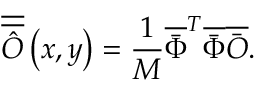<formula> <loc_0><loc_0><loc_500><loc_500>\overline { { \overline { { \hat { O } } } } } \left ( { x , y } \right ) = \frac { 1 } { M } { \overline { { \bar { \Phi } } } ^ { T } } \overline { { \bar { \Phi } } } \overline { { \bar { O } } } .</formula> 